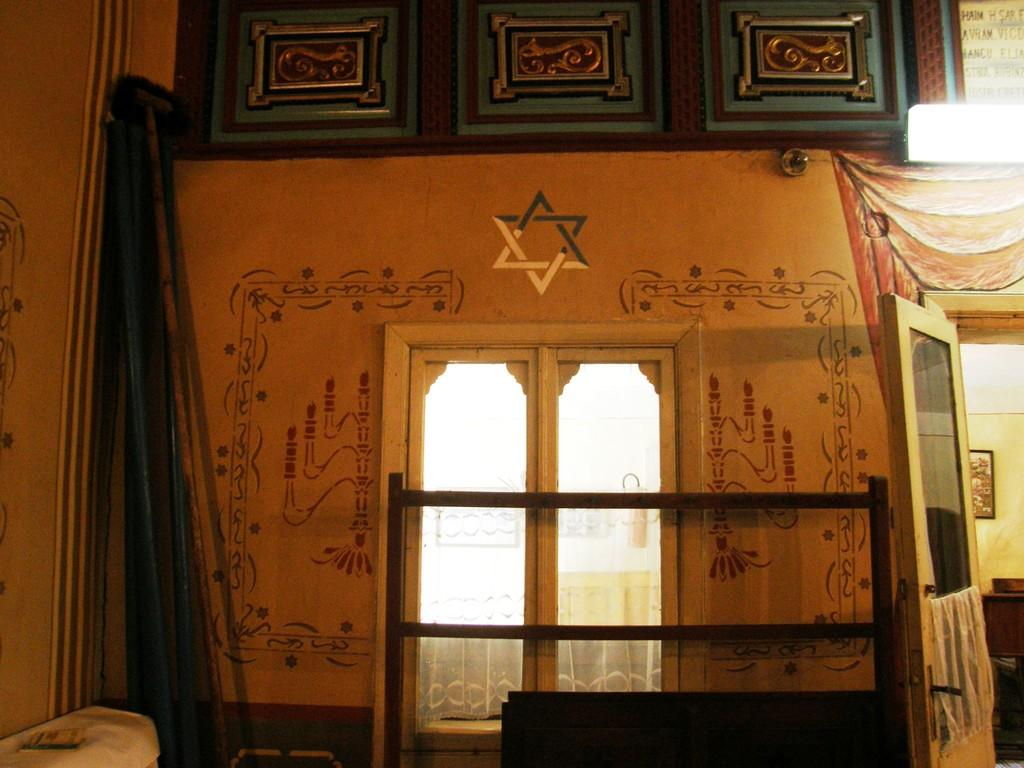Where was the image taken? The image was taken inside a room. What can be seen on the walls of the room? There are paintings on the wall. What feature allows natural light to enter the room? There is a glass window in the room. Where is the door located in the room? The door is on the right side of the room. What is present inside the room that indicates it is furnished? There is furniture inside the room. What type of suit is the person wearing in the image? There is no person present in the image, so it is not possible to determine what type of suit they might be wearing. 